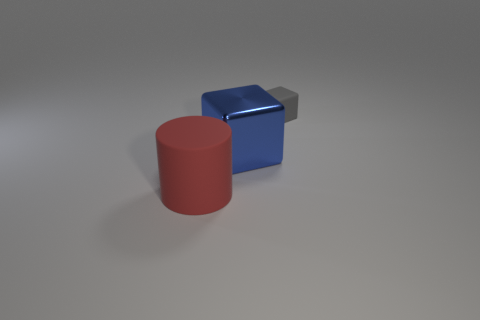Add 1 tiny matte objects. How many objects exist? 4 Subtract all cylinders. How many objects are left? 2 Add 3 gray blocks. How many gray blocks are left? 4 Add 1 large rubber objects. How many large rubber objects exist? 2 Subtract 1 blue blocks. How many objects are left? 2 Subtract all blue things. Subtract all purple balls. How many objects are left? 2 